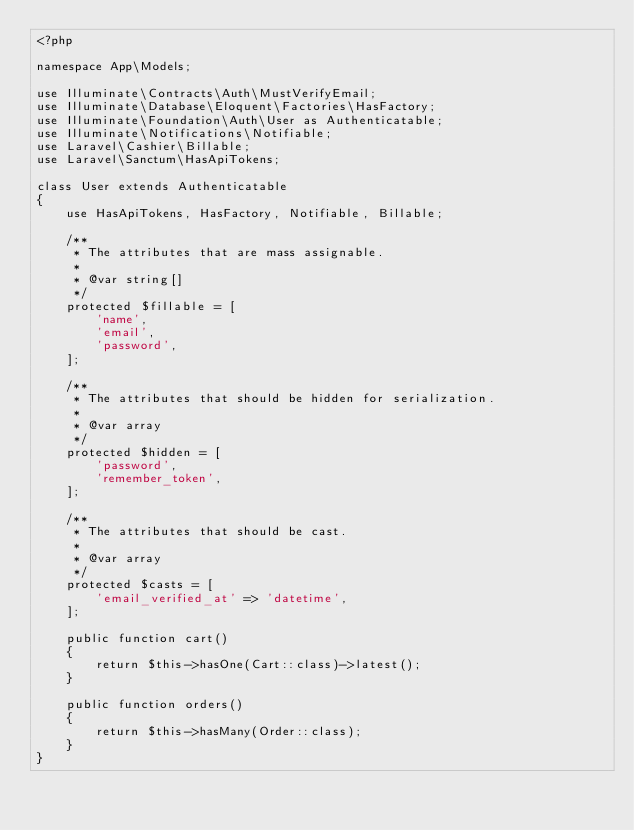<code> <loc_0><loc_0><loc_500><loc_500><_PHP_><?php

namespace App\Models;

use Illuminate\Contracts\Auth\MustVerifyEmail;
use Illuminate\Database\Eloquent\Factories\HasFactory;
use Illuminate\Foundation\Auth\User as Authenticatable;
use Illuminate\Notifications\Notifiable;
use Laravel\Cashier\Billable;
use Laravel\Sanctum\HasApiTokens;

class User extends Authenticatable
{
    use HasApiTokens, HasFactory, Notifiable, Billable;

    /**
     * The attributes that are mass assignable.
     *
     * @var string[]
     */
    protected $fillable = [
        'name',
        'email',
        'password',
    ];

    /**
     * The attributes that should be hidden for serialization.
     *
     * @var array
     */
    protected $hidden = [
        'password',
        'remember_token',
    ];

    /**
     * The attributes that should be cast.
     *
     * @var array
     */
    protected $casts = [
        'email_verified_at' => 'datetime',
    ];

    public function cart()
    {
        return $this->hasOne(Cart::class)->latest();
    }

    public function orders()
    {
        return $this->hasMany(Order::class);
    }
}
</code> 